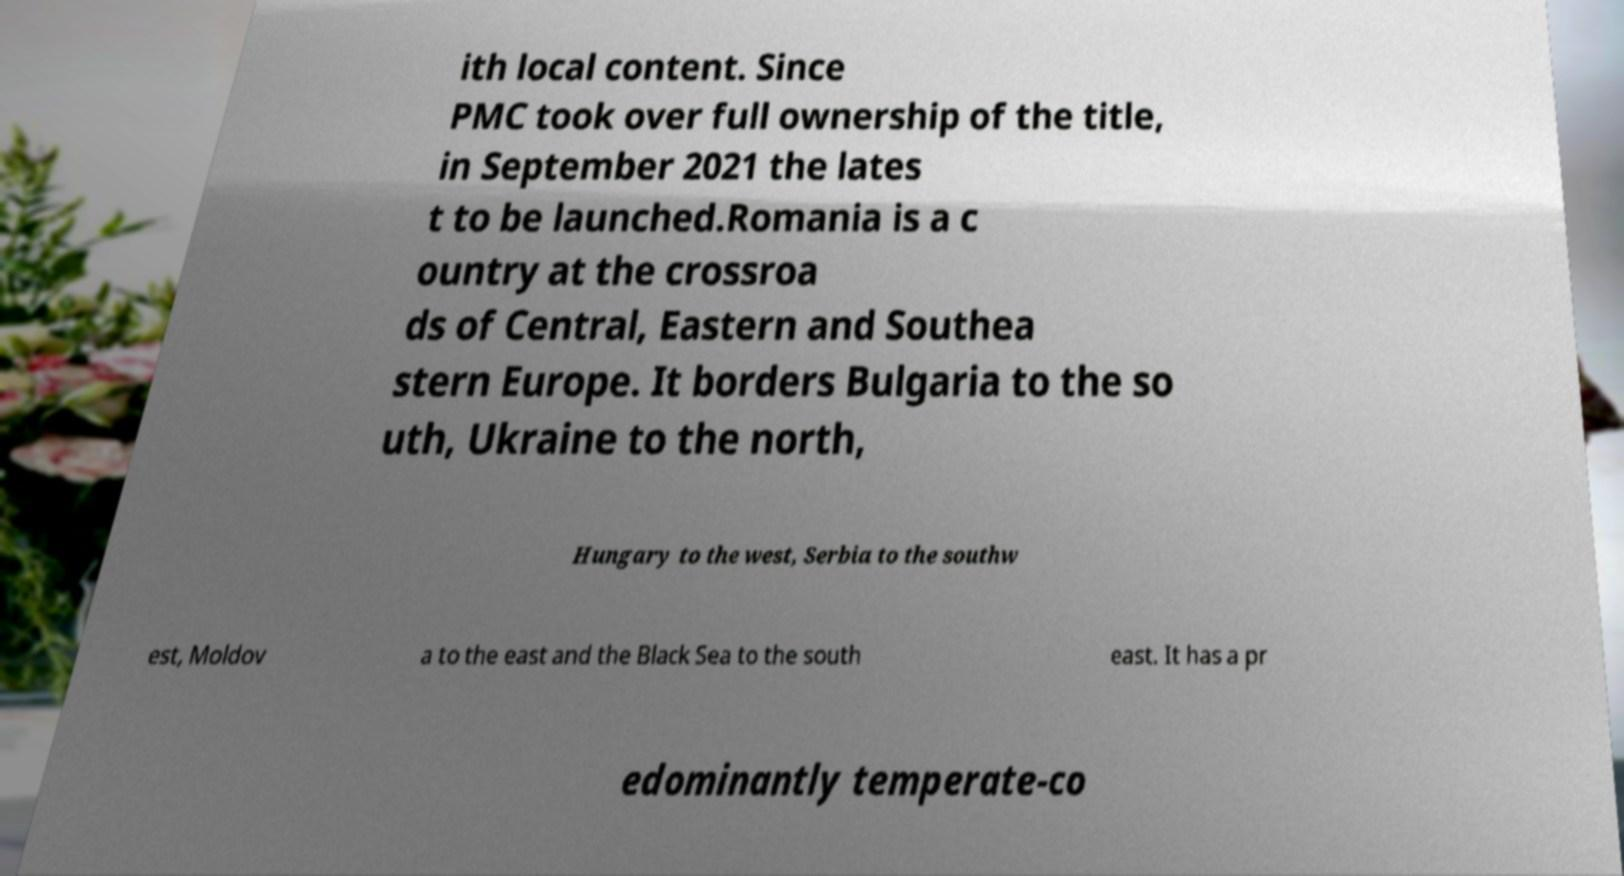Please read and relay the text visible in this image. What does it say? ith local content. Since PMC took over full ownership of the title, in September 2021 the lates t to be launched.Romania is a c ountry at the crossroa ds of Central, Eastern and Southea stern Europe. It borders Bulgaria to the so uth, Ukraine to the north, Hungary to the west, Serbia to the southw est, Moldov a to the east and the Black Sea to the south east. It has a pr edominantly temperate-co 